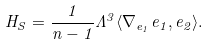Convert formula to latex. <formula><loc_0><loc_0><loc_500><loc_500>H _ { S } = \frac { 1 } { n - 1 } \Lambda ^ { 3 } \langle \nabla _ { e _ { 1 } } e _ { 1 } , e _ { 2 } \rangle .</formula> 